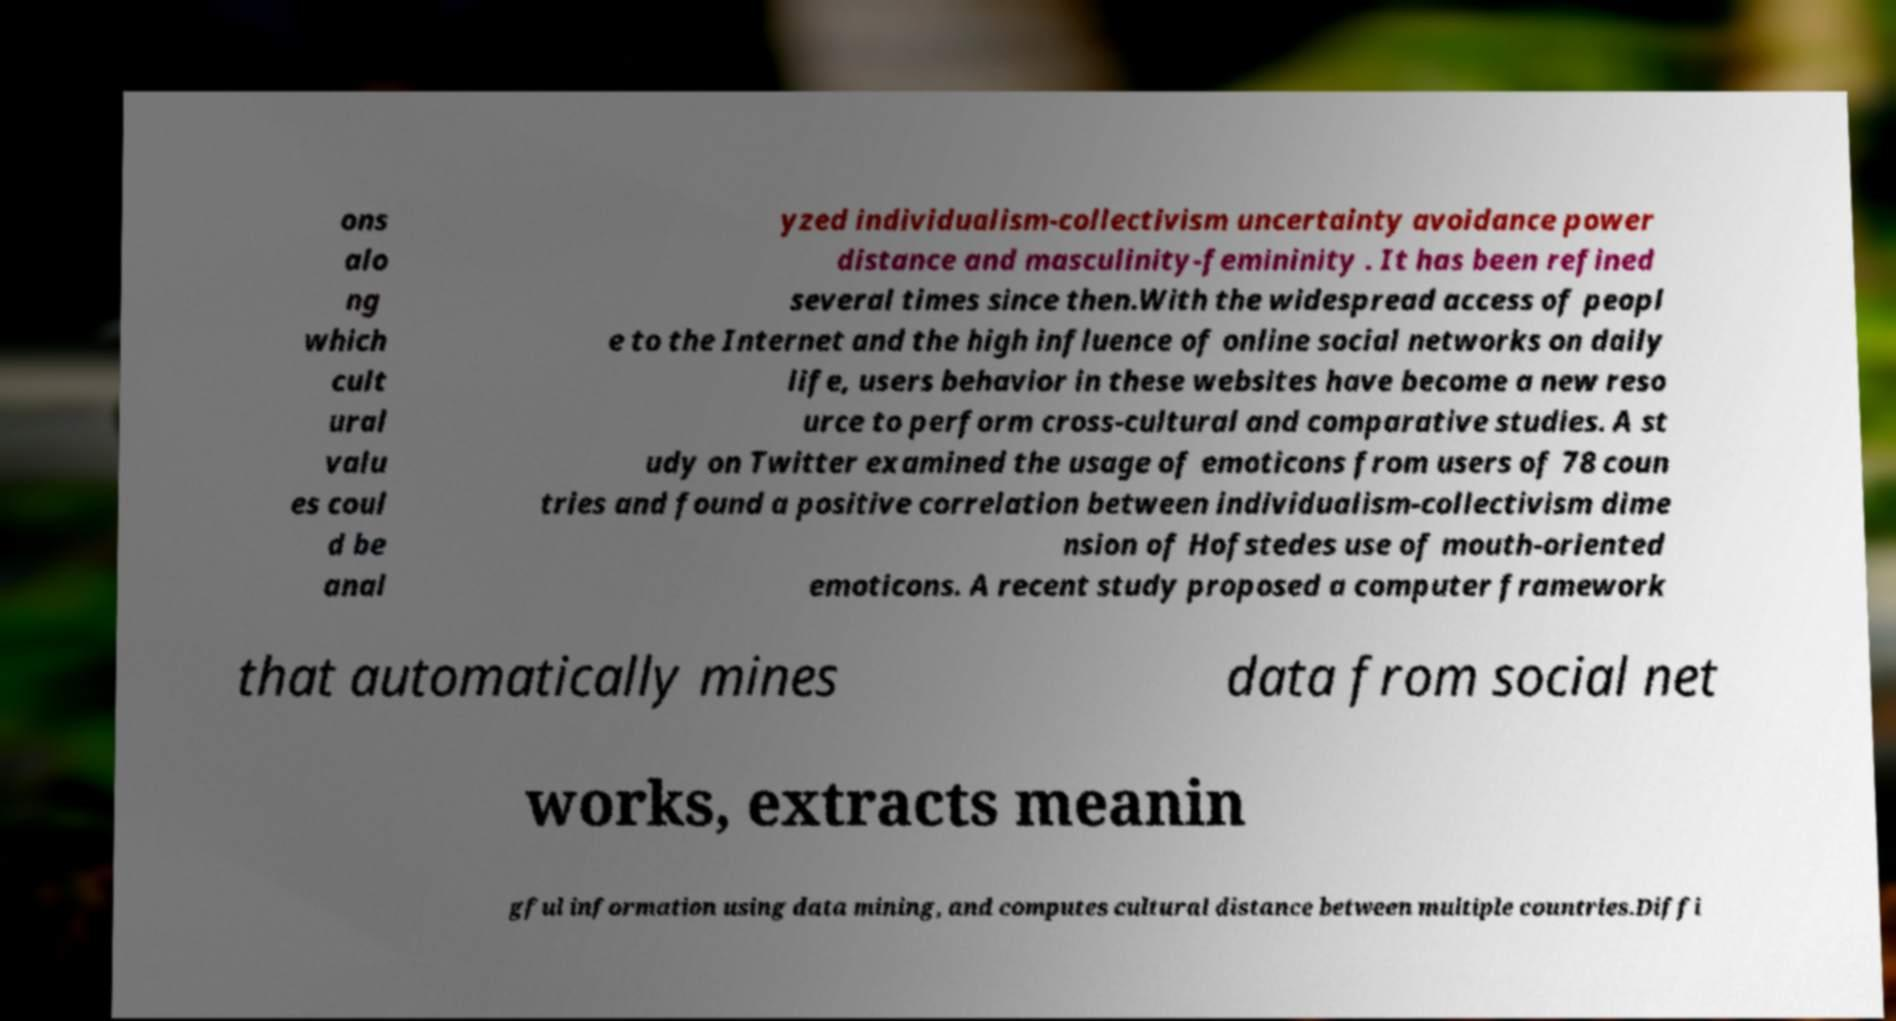Please read and relay the text visible in this image. What does it say? ons alo ng which cult ural valu es coul d be anal yzed individualism-collectivism uncertainty avoidance power distance and masculinity-femininity . It has been refined several times since then.With the widespread access of peopl e to the Internet and the high influence of online social networks on daily life, users behavior in these websites have become a new reso urce to perform cross-cultural and comparative studies. A st udy on Twitter examined the usage of emoticons from users of 78 coun tries and found a positive correlation between individualism-collectivism dime nsion of Hofstedes use of mouth-oriented emoticons. A recent study proposed a computer framework that automatically mines data from social net works, extracts meanin gful information using data mining, and computes cultural distance between multiple countries.Diffi 